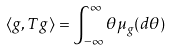<formula> <loc_0><loc_0><loc_500><loc_500>\langle g , T g \rangle = \int _ { - \infty } ^ { \infty } \theta \mu _ { g } ( d \theta )</formula> 